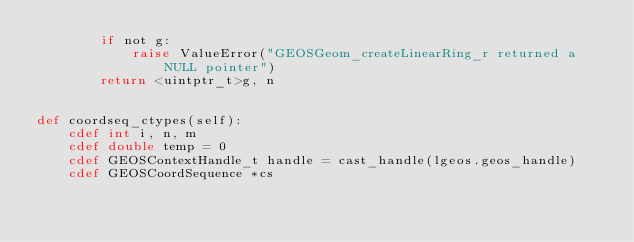Convert code to text. <code><loc_0><loc_0><loc_500><loc_500><_Cython_>        if not g:
            raise ValueError("GEOSGeom_createLinearRing_r returned a NULL pointer")
        return <uintptr_t>g, n


def coordseq_ctypes(self):
    cdef int i, n, m
    cdef double temp = 0
    cdef GEOSContextHandle_t handle = cast_handle(lgeos.geos_handle)
    cdef GEOSCoordSequence *cs</code> 